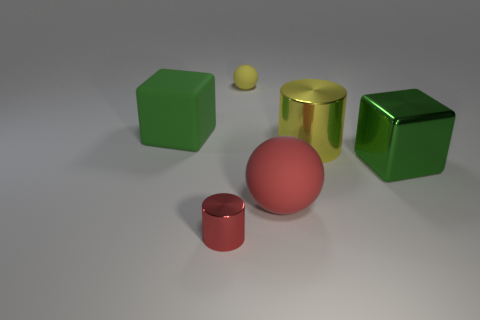What are the different shapes visible in the image? In the image, we have a variety of geometric shapes including a red cylinder, a yellow cylinder with a metallic finish, a green cube, another smaller green cube, a pink sphere, and a tiny yellow sphere. 